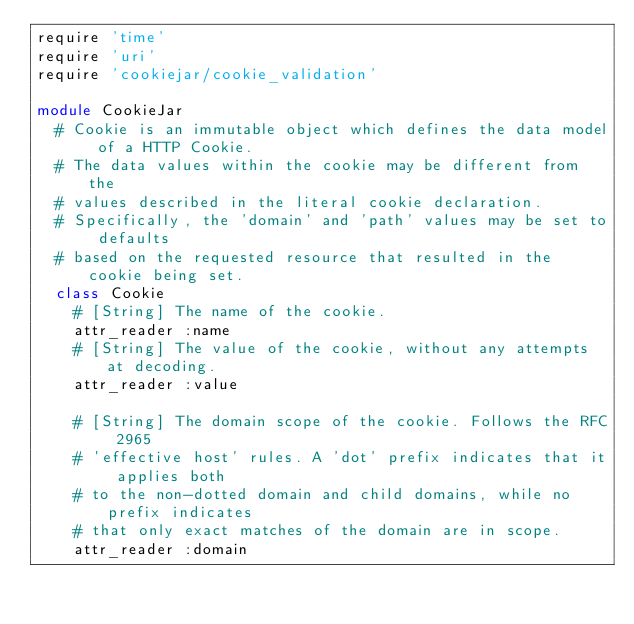Convert code to text. <code><loc_0><loc_0><loc_500><loc_500><_Ruby_>require 'time'
require 'uri'
require 'cookiejar/cookie_validation'

module CookieJar
  # Cookie is an immutable object which defines the data model of a HTTP Cookie.
  # The data values within the cookie may be different from the
  # values described in the literal cookie declaration.
  # Specifically, the 'domain' and 'path' values may be set to defaults
  # based on the requested resource that resulted in the cookie being set.
  class Cookie
    # [String] The name of the cookie.
    attr_reader :name
    # [String] The value of the cookie, without any attempts at decoding.
    attr_reader :value

    # [String] The domain scope of the cookie. Follows the RFC 2965
    # 'effective host' rules. A 'dot' prefix indicates that it applies both
    # to the non-dotted domain and child domains, while no prefix indicates
    # that only exact matches of the domain are in scope.
    attr_reader :domain
</code> 